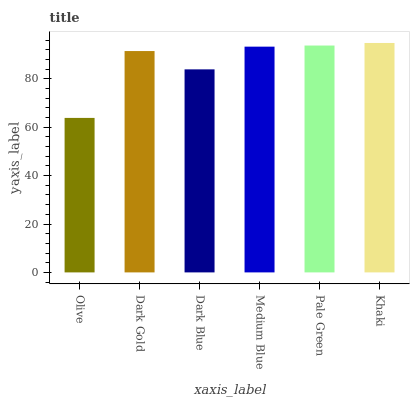Is Olive the minimum?
Answer yes or no. Yes. Is Khaki the maximum?
Answer yes or no. Yes. Is Dark Gold the minimum?
Answer yes or no. No. Is Dark Gold the maximum?
Answer yes or no. No. Is Dark Gold greater than Olive?
Answer yes or no. Yes. Is Olive less than Dark Gold?
Answer yes or no. Yes. Is Olive greater than Dark Gold?
Answer yes or no. No. Is Dark Gold less than Olive?
Answer yes or no. No. Is Medium Blue the high median?
Answer yes or no. Yes. Is Dark Gold the low median?
Answer yes or no. Yes. Is Dark Blue the high median?
Answer yes or no. No. Is Pale Green the low median?
Answer yes or no. No. 